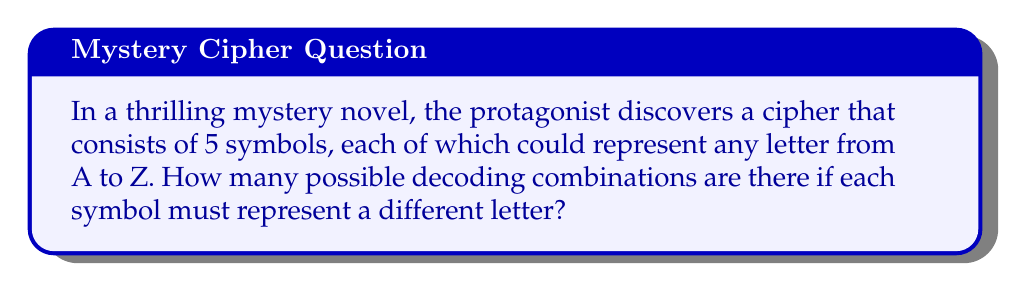Help me with this question. Let's approach this step-by-step:

1) We have 5 symbols, and each symbol can be any letter from A to Z. There are 26 letters in the alphabet.

2) For the first symbol, we have 26 choices, as it can be any letter.

3) For the second symbol, we have 25 choices, as it must be different from the first.

4) For the third symbol, we have 24 choices, and so on.

5) This scenario follows the multiplication principle of counting.

6) The total number of possible combinations is therefore:

   $$26 \times 25 \times 24 \times 23 \times 22$$

7) This is equivalent to the permutation formula:

   $$P(26,5) = \frac{26!}{(26-5)!} = \frac{26!}{21!}$$

8) Calculating this:
   
   $$\frac{26!}{21!} = 26 \times 25 \times 24 \times 23 \times 22 = 7,893,600$$

Therefore, there are 7,893,600 possible decoding combinations.
Answer: 7,893,600 